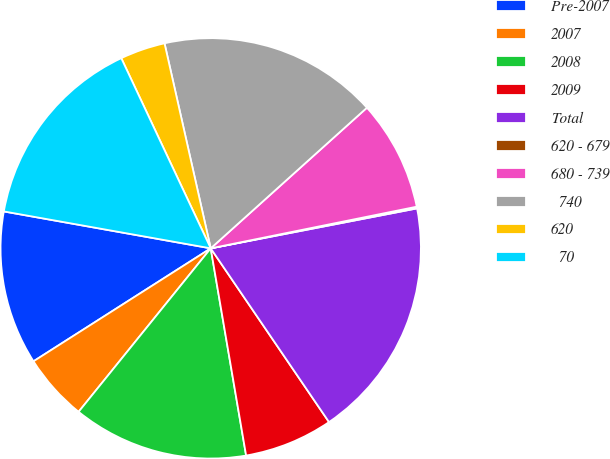<chart> <loc_0><loc_0><loc_500><loc_500><pie_chart><fcel>Pre-2007<fcel>2007<fcel>2008<fcel>2009<fcel>Total<fcel>620 - 679<fcel>680 - 739<fcel>≥ 740<fcel>620<fcel>≤ 70<nl><fcel>11.84%<fcel>5.15%<fcel>13.51%<fcel>6.82%<fcel>18.53%<fcel>0.13%<fcel>8.49%<fcel>16.86%<fcel>3.47%<fcel>15.19%<nl></chart> 